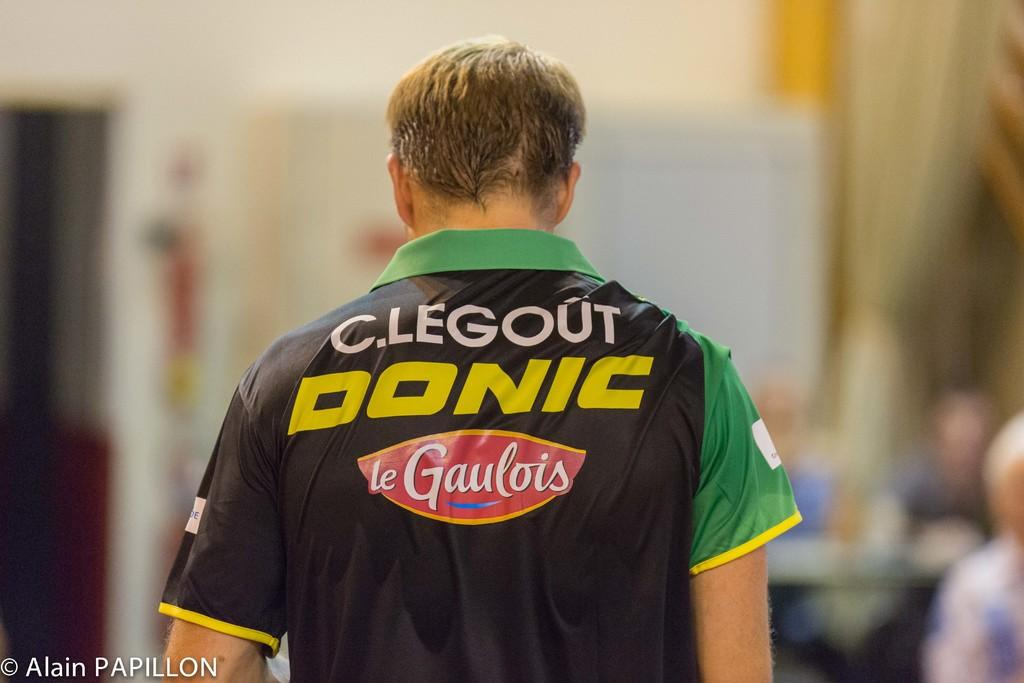<image>
Offer a succinct explanation of the picture presented. Man wearing a green and black jersey which says "Donic" on it. 